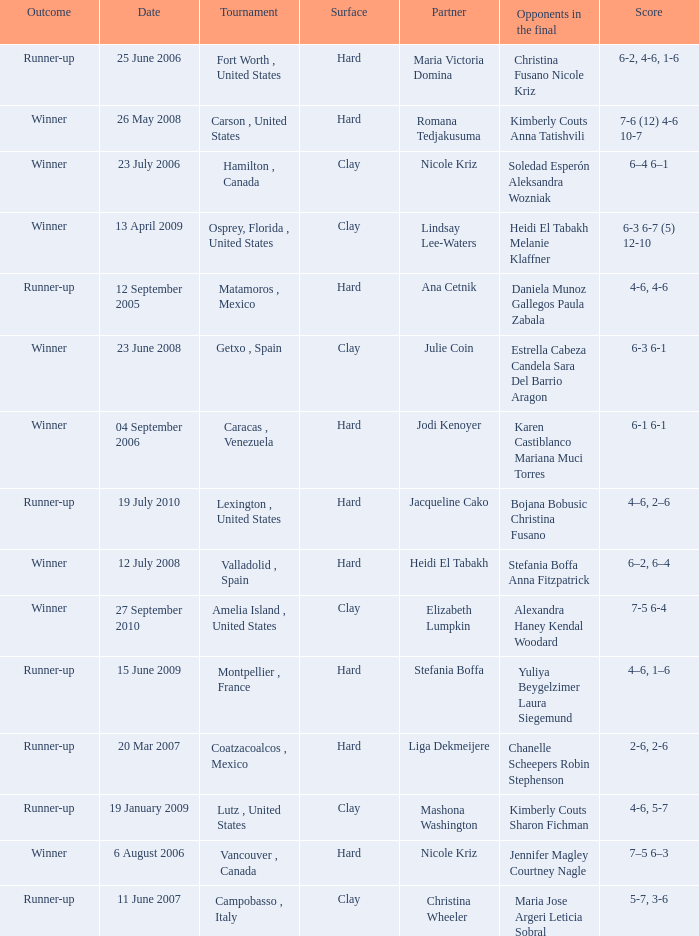Who were the opponents during the final when christina wheeler was partner? Maria Jose Argeri Leticia Sobral. 